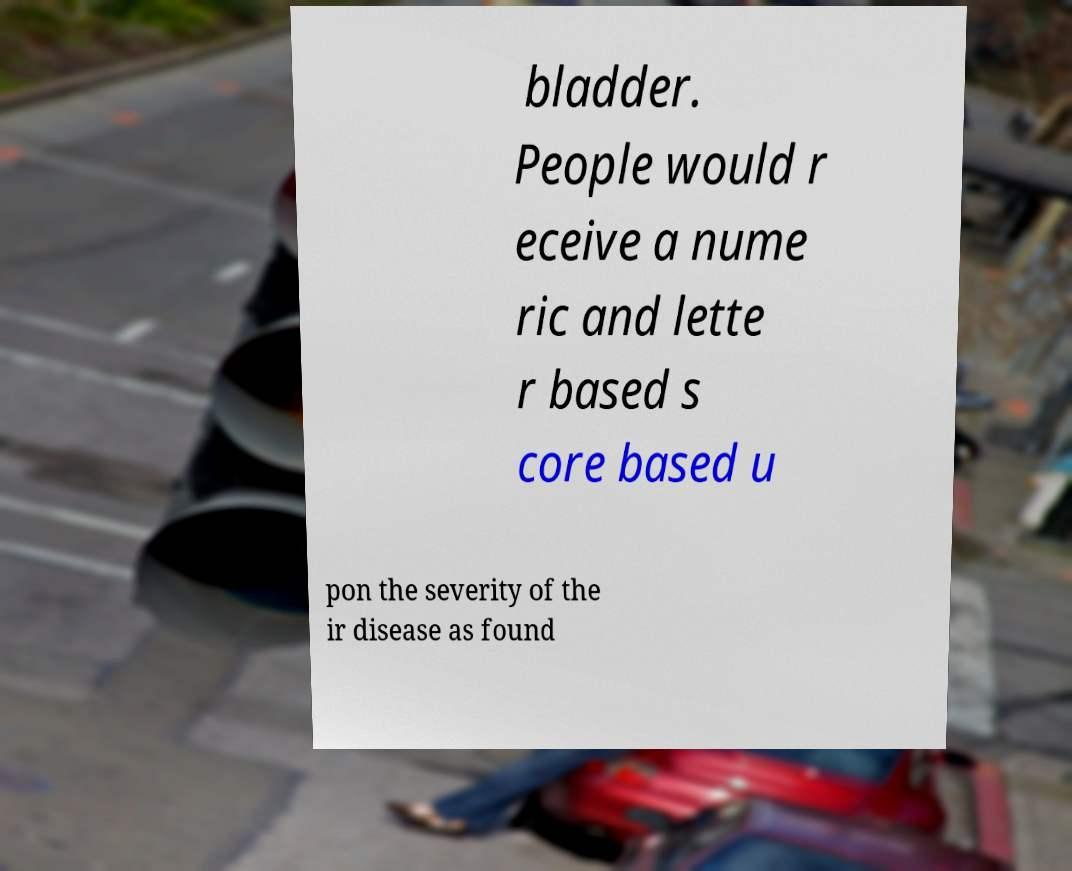Can you read and provide the text displayed in the image?This photo seems to have some interesting text. Can you extract and type it out for me? bladder. People would r eceive a nume ric and lette r based s core based u pon the severity of the ir disease as found 